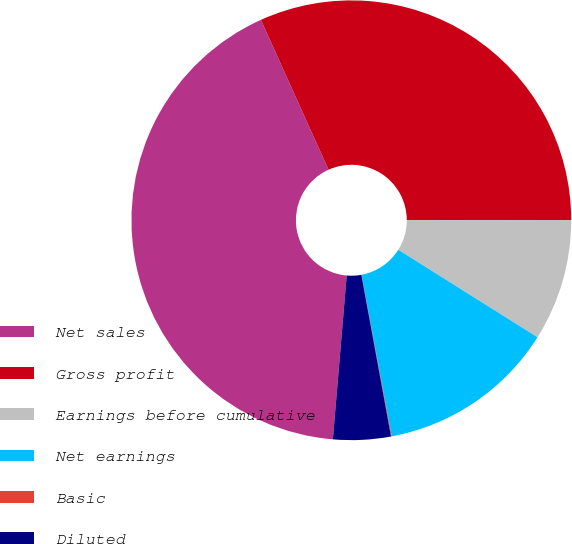Convert chart to OTSL. <chart><loc_0><loc_0><loc_500><loc_500><pie_chart><fcel>Net sales<fcel>Gross profit<fcel>Earnings before cumulative<fcel>Net earnings<fcel>Basic<fcel>Diluted<nl><fcel>41.91%<fcel>31.73%<fcel>8.95%<fcel>13.13%<fcel>0.05%<fcel>4.23%<nl></chart> 